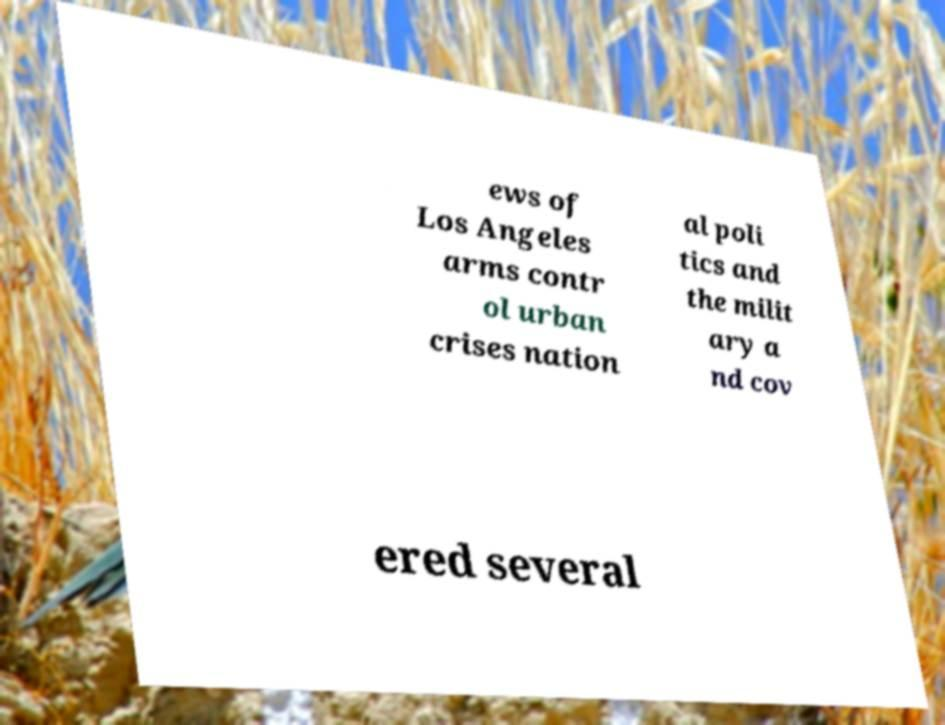Please read and relay the text visible in this image. What does it say? ews of Los Angeles arms contr ol urban crises nation al poli tics and the milit ary a nd cov ered several 